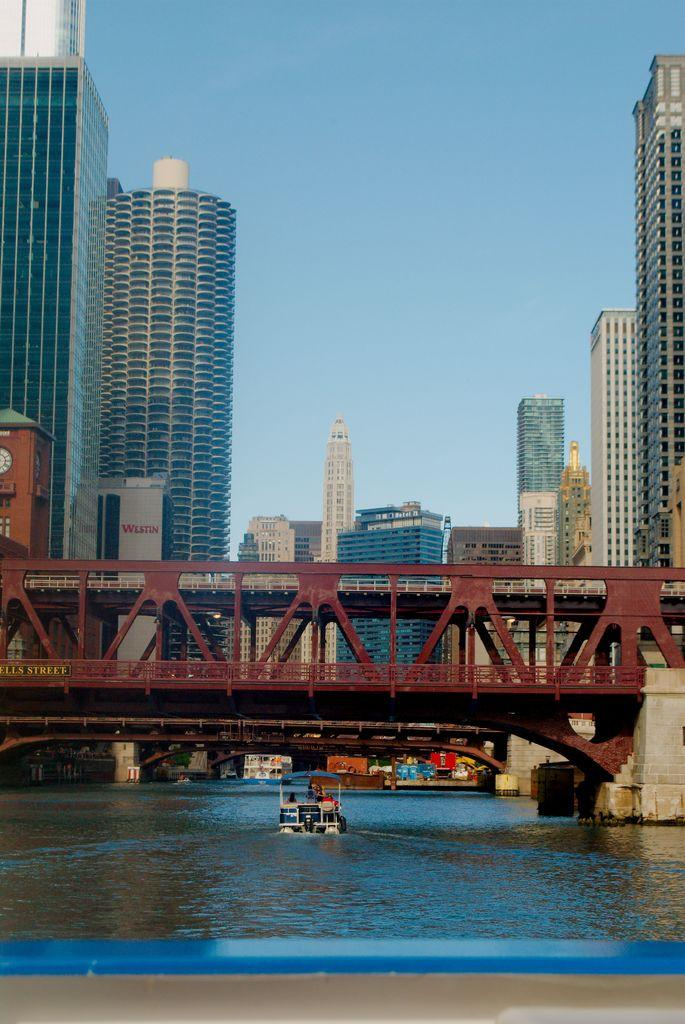What type of structures can be seen in the image? There are buildings in the image. What connects the two sides of the water in the image? There is a bridge in the image. What is the body of water in the image used for? The presence of a boat suggests that the water is used for transportation. What can be seen in the background of the image? The sky is visible in the background of the image. Where is the nest of the bird in the image? There is no bird or nest present in the image. What is the mass of the comfort provided by the bridge in the image? The image does not provide information about the comfort or mass of the bridge. 